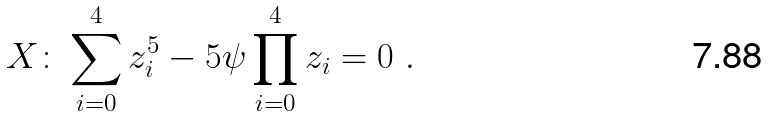<formula> <loc_0><loc_0><loc_500><loc_500>X \colon \sum _ { i = 0 } ^ { 4 } z _ { i } ^ { 5 } - 5 \psi \prod _ { i = 0 } ^ { 4 } z _ { i } = 0 \ .</formula> 